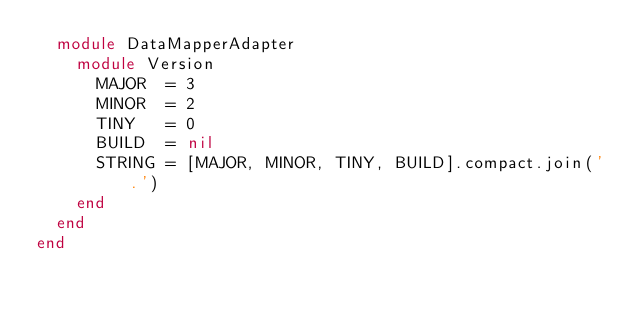Convert code to text. <code><loc_0><loc_0><loc_500><loc_500><_Ruby_>  module DataMapperAdapter
    module Version
      MAJOR  = 3
      MINOR  = 2
      TINY   = 0
      BUILD  = nil
      STRING = [MAJOR, MINOR, TINY, BUILD].compact.join('.')
    end
  end
end
</code> 